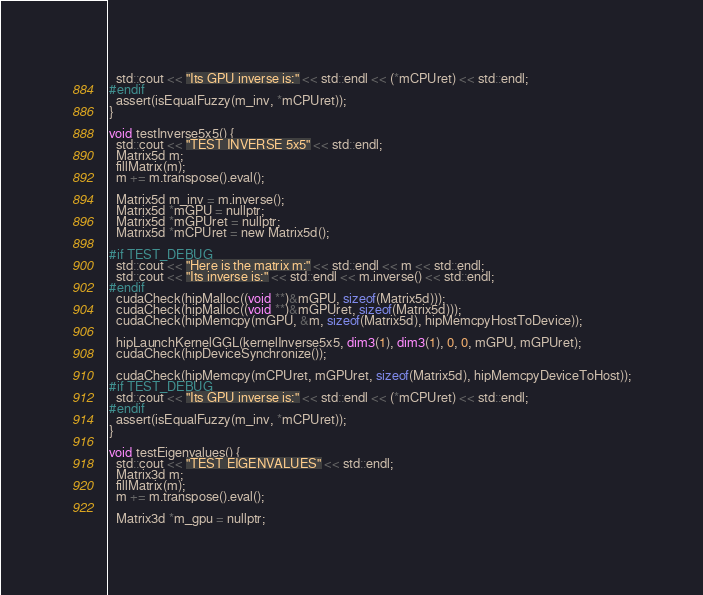<code> <loc_0><loc_0><loc_500><loc_500><_Cuda_>  std::cout << "Its GPU inverse is:" << std::endl << (*mCPUret) << std::endl;
#endif
  assert(isEqualFuzzy(m_inv, *mCPUret));
}

void testInverse5x5() {
  std::cout << "TEST INVERSE 5x5" << std::endl;
  Matrix5d m;
  fillMatrix(m);
  m += m.transpose().eval();

  Matrix5d m_inv = m.inverse();
  Matrix5d *mGPU = nullptr;
  Matrix5d *mGPUret = nullptr;
  Matrix5d *mCPUret = new Matrix5d();

#if TEST_DEBUG
  std::cout << "Here is the matrix m:" << std::endl << m << std::endl;
  std::cout << "Its inverse is:" << std::endl << m.inverse() << std::endl;
#endif
  cudaCheck(hipMalloc((void **)&mGPU, sizeof(Matrix5d)));
  cudaCheck(hipMalloc((void **)&mGPUret, sizeof(Matrix5d)));
  cudaCheck(hipMemcpy(mGPU, &m, sizeof(Matrix5d), hipMemcpyHostToDevice));

  hipLaunchKernelGGL(kernelInverse5x5, dim3(1), dim3(1), 0, 0, mGPU, mGPUret);
  cudaCheck(hipDeviceSynchronize());

  cudaCheck(hipMemcpy(mCPUret, mGPUret, sizeof(Matrix5d), hipMemcpyDeviceToHost));
#if TEST_DEBUG
  std::cout << "Its GPU inverse is:" << std::endl << (*mCPUret) << std::endl;
#endif
  assert(isEqualFuzzy(m_inv, *mCPUret));
}

void testEigenvalues() {
  std::cout << "TEST EIGENVALUES" << std::endl;
  Matrix3d m;
  fillMatrix(m);
  m += m.transpose().eval();

  Matrix3d *m_gpu = nullptr;</code> 